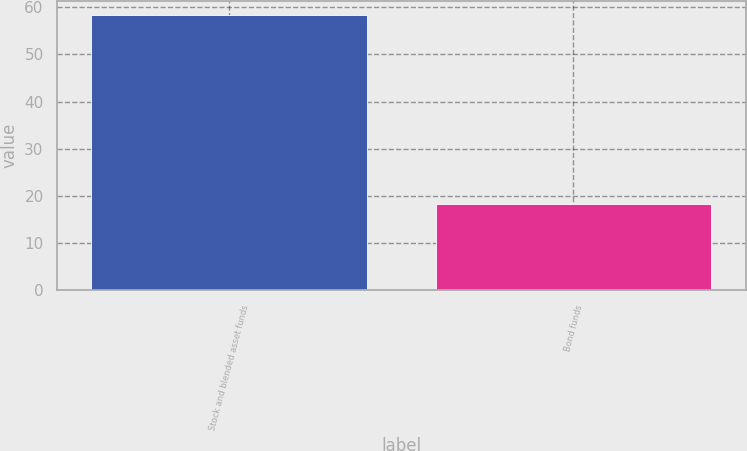<chart> <loc_0><loc_0><loc_500><loc_500><bar_chart><fcel>Stock and blended asset funds<fcel>Bond funds<nl><fcel>58.4<fcel>18.2<nl></chart> 